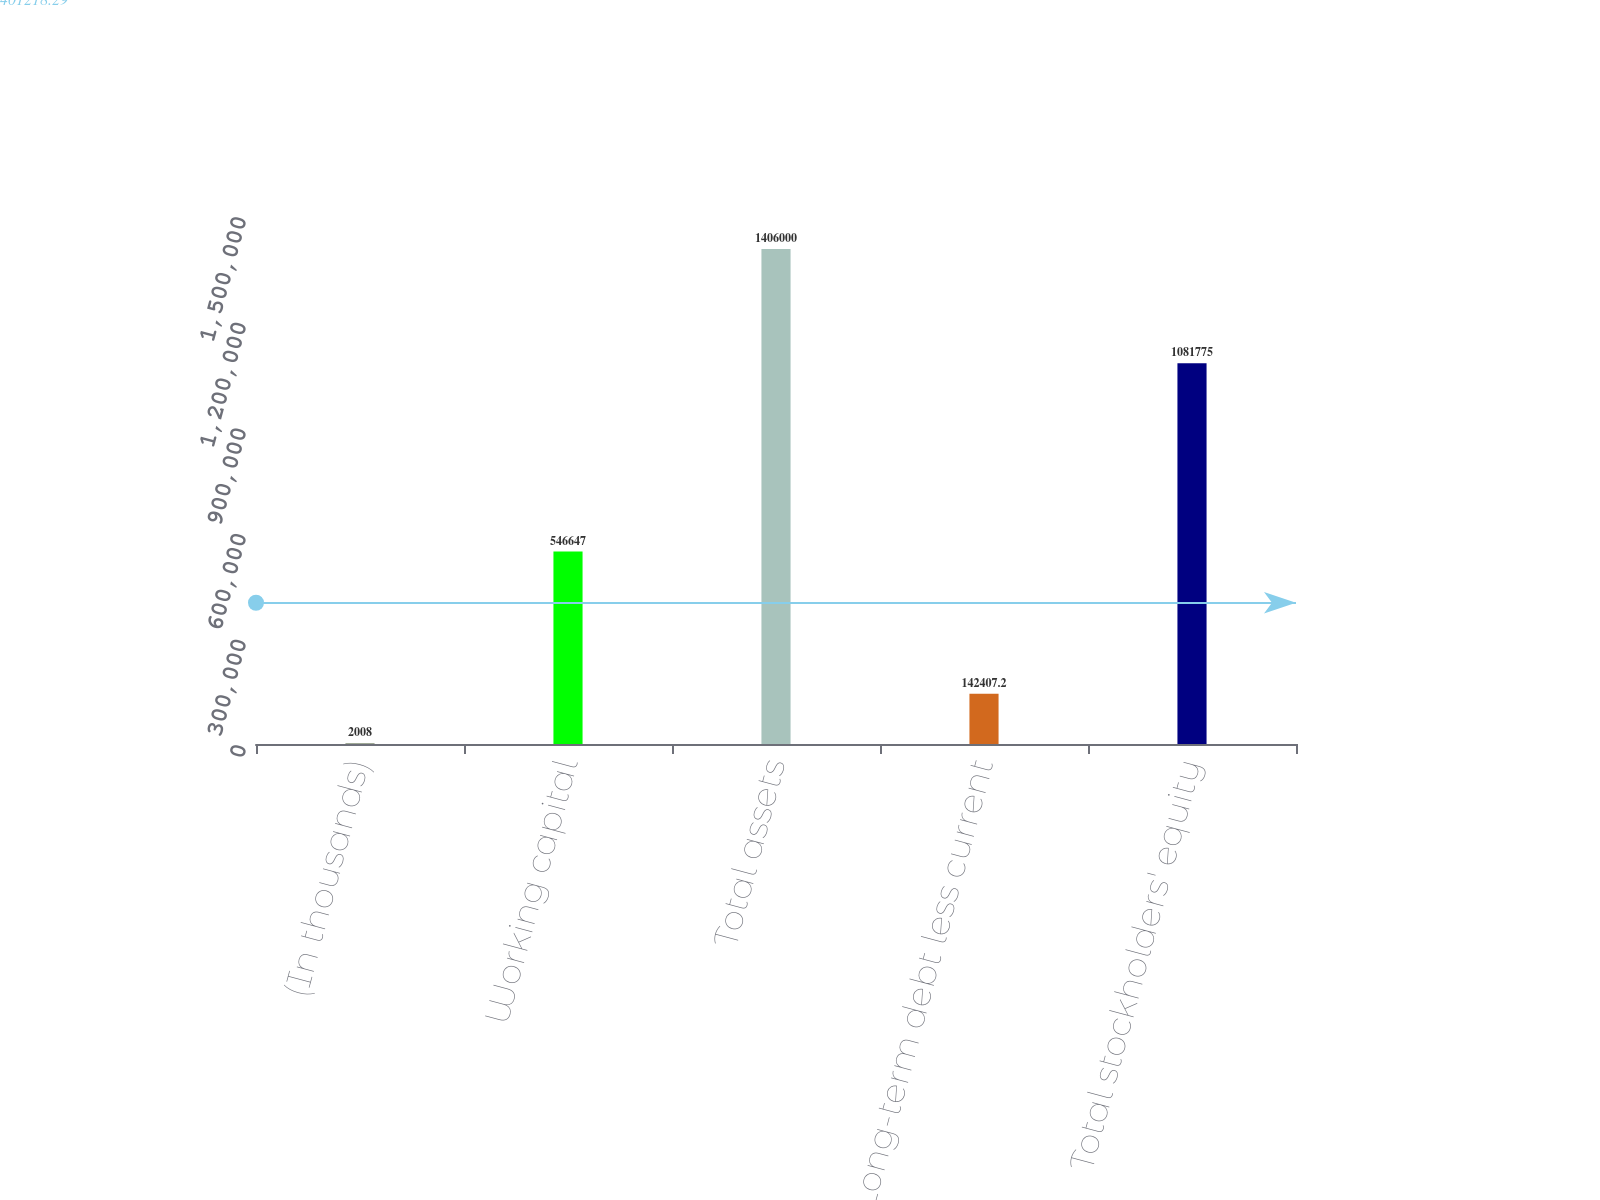<chart> <loc_0><loc_0><loc_500><loc_500><bar_chart><fcel>(In thousands)<fcel>Working capital<fcel>Total assets<fcel>Long-term debt less current<fcel>Total stockholders' equity<nl><fcel>2008<fcel>546647<fcel>1.406e+06<fcel>142407<fcel>1.08178e+06<nl></chart> 